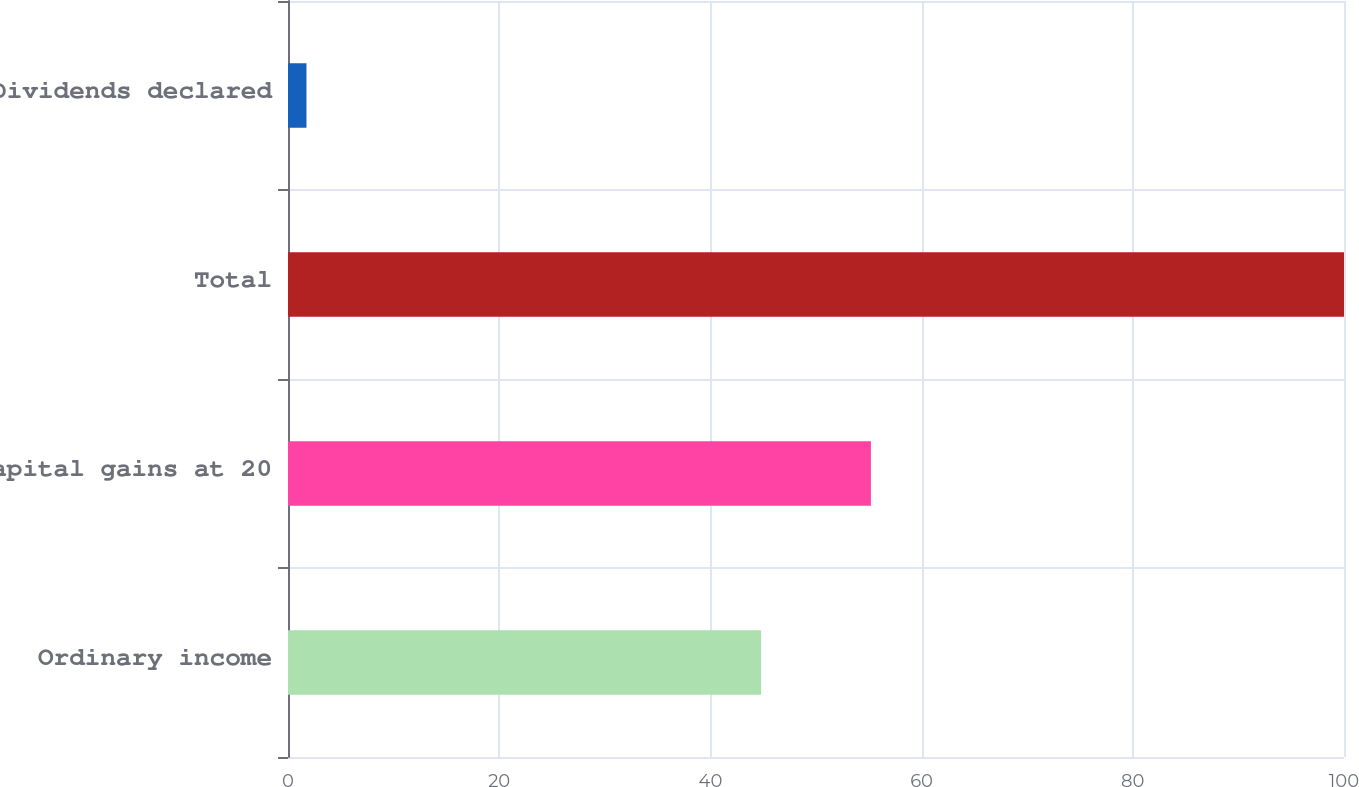Convert chart. <chart><loc_0><loc_0><loc_500><loc_500><bar_chart><fcel>Ordinary income<fcel>Capital gains at 20<fcel>Total<fcel>Dividends declared<nl><fcel>44.8<fcel>55.2<fcel>100<fcel>1.75<nl></chart> 